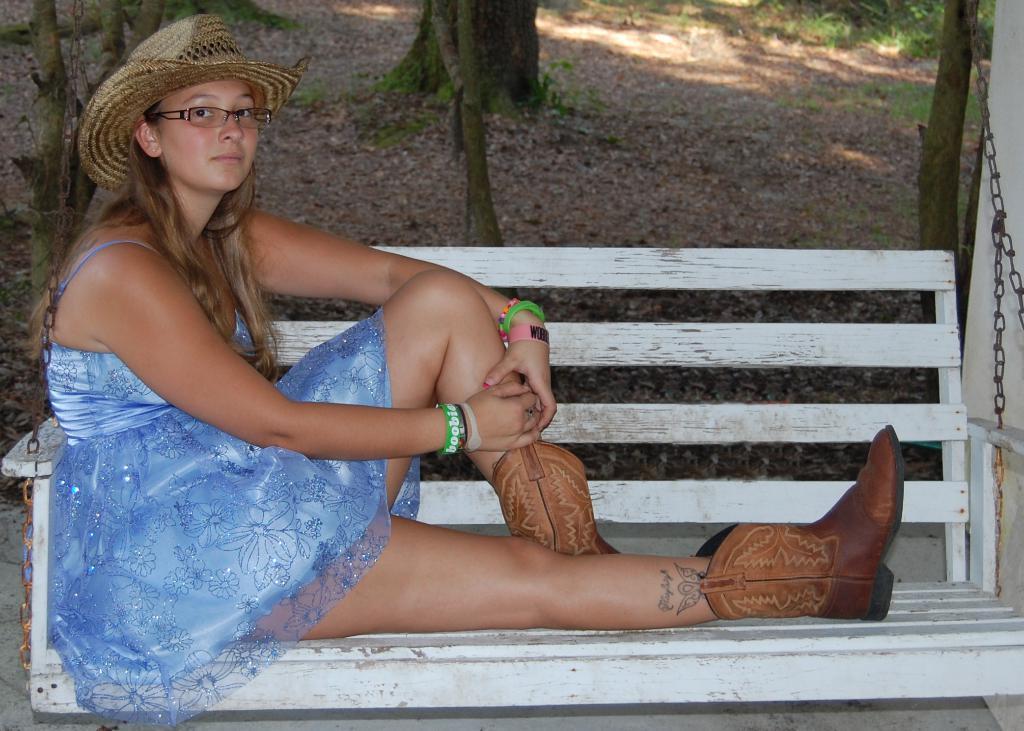How would you summarize this image in a sentence or two? In the image there is a woman in blue frock,boots and hat sitting on bench and behind there are trees on the land. 